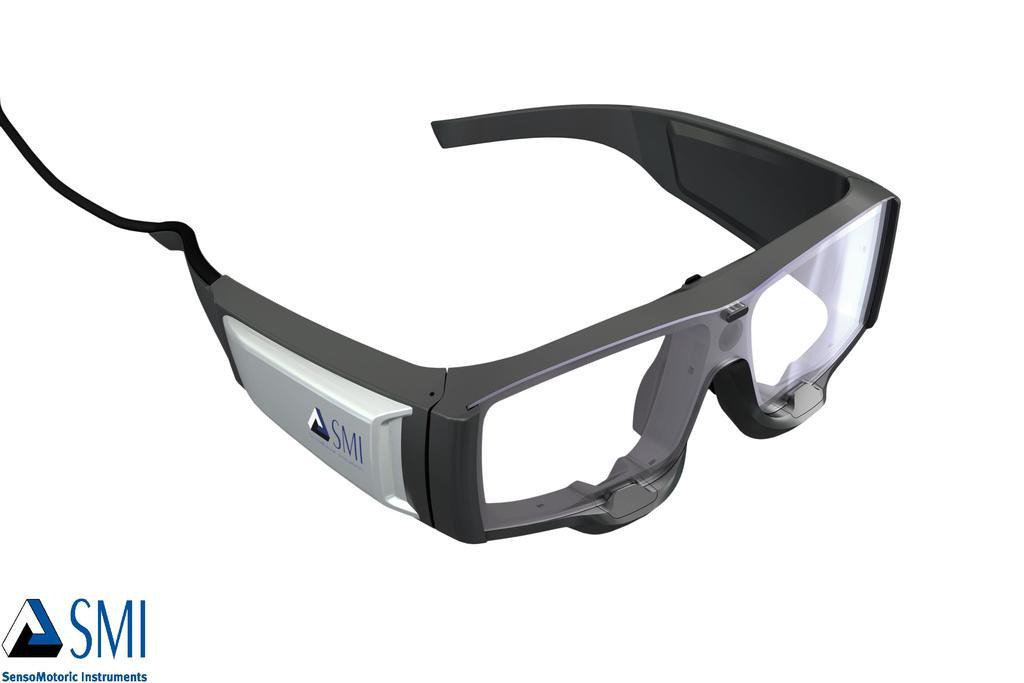What type of equipment is visible in the image? There is a pair of goggles in the image. Can you describe any specific features of the goggles? Yes, there is a company logo on the left side of the goggles. Is there any additional information or markings in the image? Yes, there is a watermark in the bottom left corner of the image. What is the name of the person who achieved a new record while wearing the goggles in the image? There is no information about any achievements or records in the image; it only shows a pair of goggles with a company logo and a watermark. 